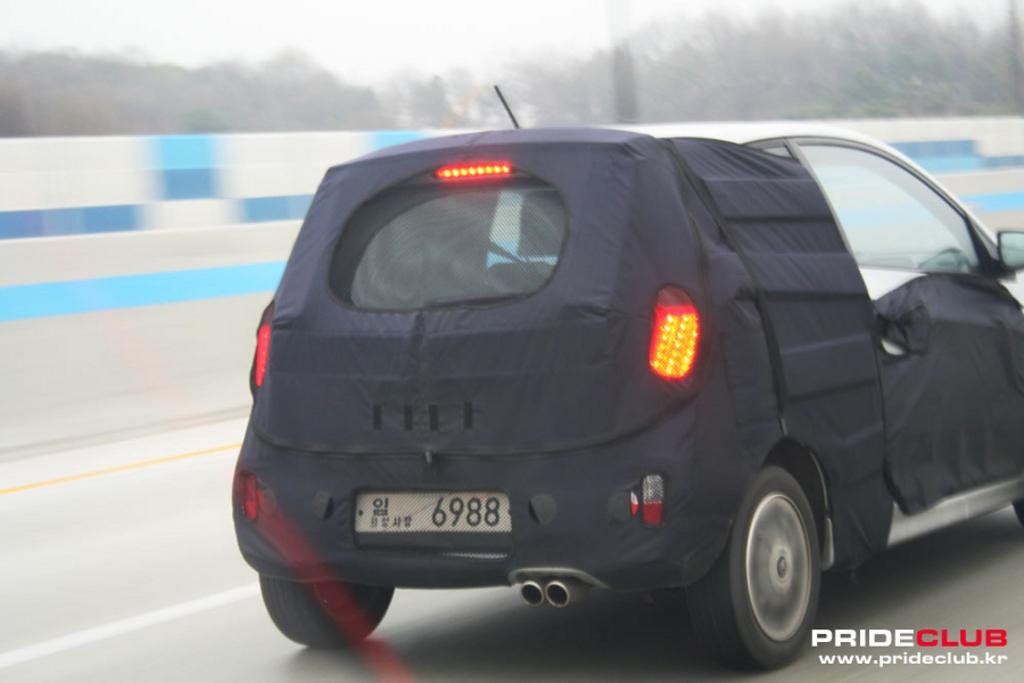What color is the car in the image? The car in the image is black. Where is the car located in the image? The car is present on the road. What can be seen in the distance in the image? There are trees visible in the distance. What type of substance is being burned in the image? There is no substance being burned in the image; it only features a black colored car on the road with trees in the distance. 